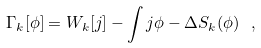<formula> <loc_0><loc_0><loc_500><loc_500>\Gamma _ { k } [ \phi ] = W _ { k } [ j ] - \int j \phi - \Delta S _ { k } ( \phi ) \, \ ,</formula> 